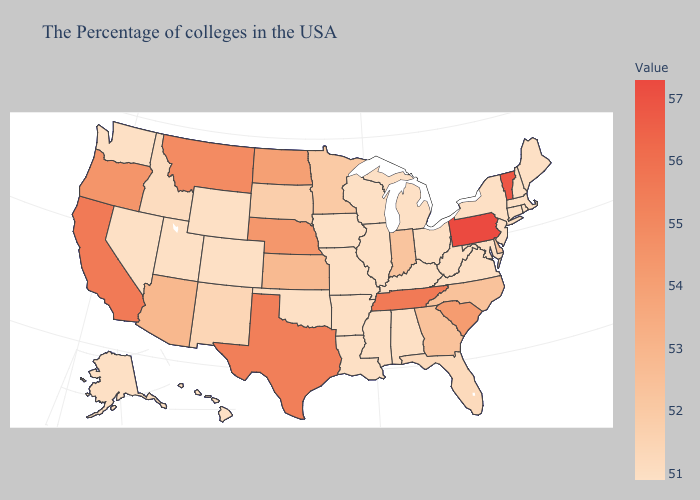Is the legend a continuous bar?
Be succinct. Yes. Does Vermont have the highest value in the USA?
Short answer required. No. Among the states that border Indiana , which have the highest value?
Quick response, please. Ohio, Michigan, Kentucky, Illinois. Is the legend a continuous bar?
Give a very brief answer. Yes. Among the states that border New Jersey , which have the lowest value?
Short answer required. New York. 